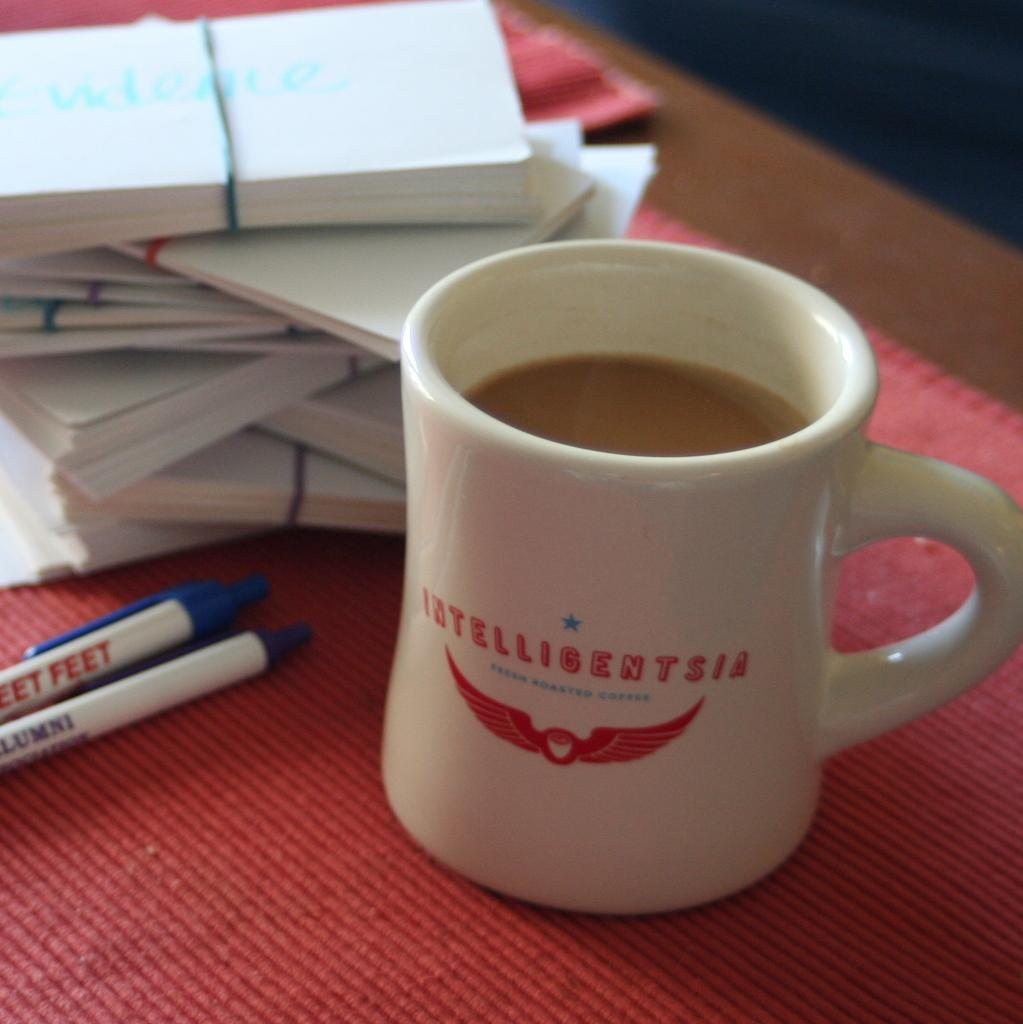What objects are bundled together in the image? There are paper bundles in the image. What is located in the middle of the image? There is a cup in the middle of the image. What writing instruments are visible in the image? There are pens on the left side of the image. What type of surface is the cloth placed on in the image? The cloth is placed on a wooden surface in the image. What type of crow is sitting on the wooden surface in the image? There is no crow present in the image; it only features paper bundles, a cup, pens, and a cloth on a wooden surface. What type of plant is growing on the left side of the image? There is no plant present in the image; it only features paper bundles, a cup, pens, and a cloth on a wooden surface. 